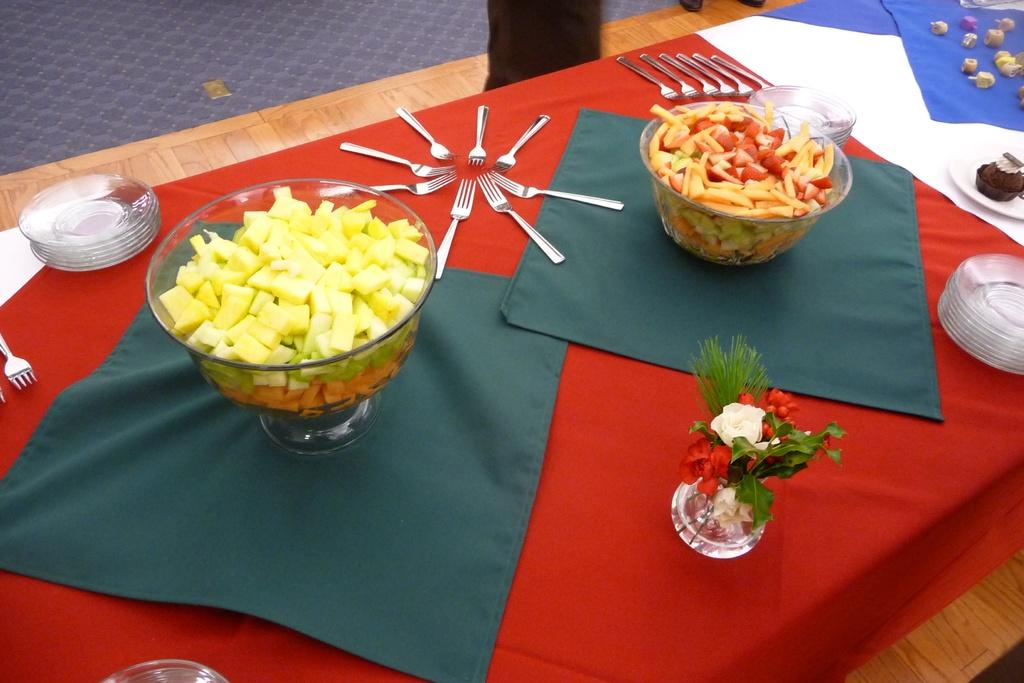What is covering the table in the image? There is a cloth on the table. What decorative item can be seen on the table? There are flowers in a vase on the table. What type of dishware is present on the table? There are bowls, forks, and plates on the table. What is the purpose of the forks on the table? The forks are likely used for eating the food on the table. What can be found on the table besides tableware? There is food on the table. What type of fruit is being used as a tooth on the table? There is no fruit or tooth present on the table in the image. How many dolls are sitting on the table? There are no dolls present on the table in the image. 